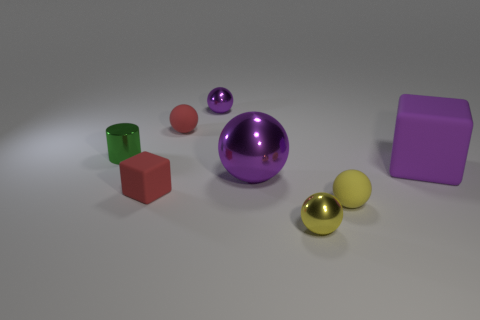Do the shiny object to the left of the tiny purple object and the shiny thing in front of the tiny red block have the same shape? no 